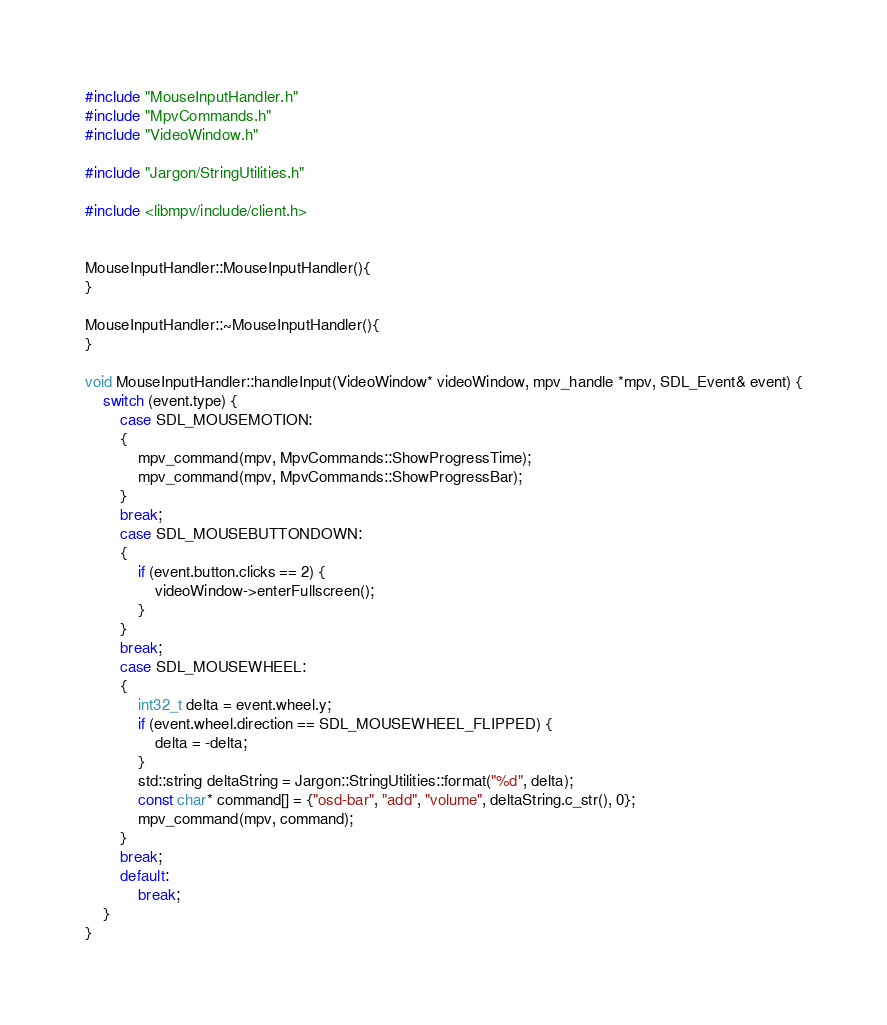<code> <loc_0><loc_0><loc_500><loc_500><_C++_>#include "MouseInputHandler.h"
#include "MpvCommands.h"
#include "VideoWindow.h"

#include "Jargon/StringUtilities.h"

#include <libmpv/include/client.h>


MouseInputHandler::MouseInputHandler(){
}

MouseInputHandler::~MouseInputHandler(){
}

void MouseInputHandler::handleInput(VideoWindow* videoWindow, mpv_handle *mpv, SDL_Event& event) {
	switch (event.type) {
		case SDL_MOUSEMOTION:
		{
			mpv_command(mpv, MpvCommands::ShowProgressTime);
			mpv_command(mpv, MpvCommands::ShowProgressBar);
		}
		break;
		case SDL_MOUSEBUTTONDOWN:
		{
			if (event.button.clicks == 2) {
				videoWindow->enterFullscreen();
			}
		}
		break;
		case SDL_MOUSEWHEEL:
		{
			int32_t delta = event.wheel.y;
			if (event.wheel.direction == SDL_MOUSEWHEEL_FLIPPED) {
				delta = -delta;
			}
			std::string deltaString = Jargon::StringUtilities::format("%d", delta);
			const char* command[] = {"osd-bar", "add", "volume", deltaString.c_str(), 0};
			mpv_command(mpv, command);
		}
		break;
		default:
			break;
	}
}
</code> 